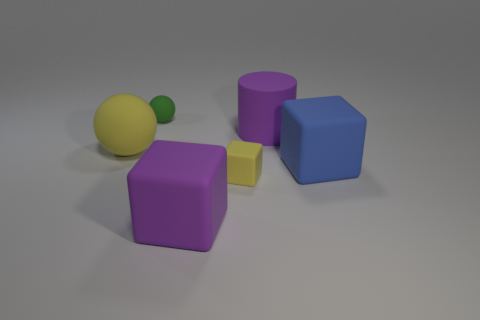What is the color of the cylinder that is the same size as the purple rubber cube? In the image, there are no cylinders that match the size of the cubes shown. There is a purple cube, but the only cylinder visible is much smaller and yellow in color. 